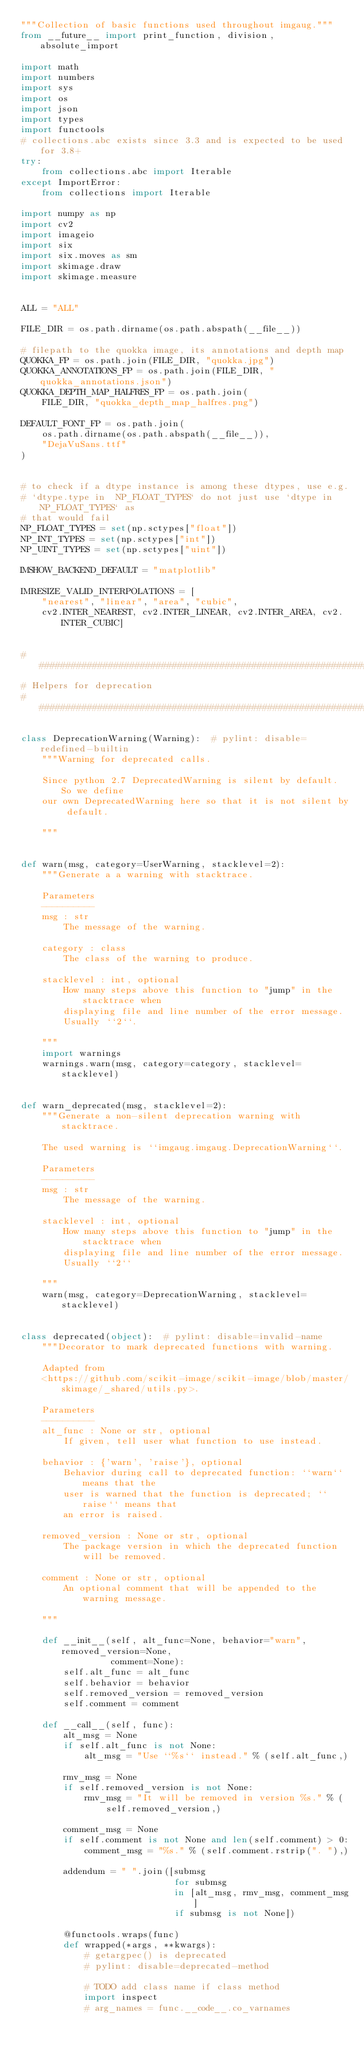<code> <loc_0><loc_0><loc_500><loc_500><_Python_>"""Collection of basic functions used throughout imgaug."""
from __future__ import print_function, division, absolute_import

import math
import numbers
import sys
import os
import json
import types
import functools
# collections.abc exists since 3.3 and is expected to be used for 3.8+
try:
    from collections.abc import Iterable
except ImportError:
    from collections import Iterable

import numpy as np
import cv2
import imageio
import six
import six.moves as sm
import skimage.draw
import skimage.measure


ALL = "ALL"

FILE_DIR = os.path.dirname(os.path.abspath(__file__))

# filepath to the quokka image, its annotations and depth map
QUOKKA_FP = os.path.join(FILE_DIR, "quokka.jpg")
QUOKKA_ANNOTATIONS_FP = os.path.join(FILE_DIR, "quokka_annotations.json")
QUOKKA_DEPTH_MAP_HALFRES_FP = os.path.join(
    FILE_DIR, "quokka_depth_map_halfres.png")

DEFAULT_FONT_FP = os.path.join(
    os.path.dirname(os.path.abspath(__file__)),
    "DejaVuSans.ttf"
)


# to check if a dtype instance is among these dtypes, use e.g.
# `dtype.type in  NP_FLOAT_TYPES` do not just use `dtype in NP_FLOAT_TYPES` as
# that would fail
NP_FLOAT_TYPES = set(np.sctypes["float"])
NP_INT_TYPES = set(np.sctypes["int"])
NP_UINT_TYPES = set(np.sctypes["uint"])

IMSHOW_BACKEND_DEFAULT = "matplotlib"

IMRESIZE_VALID_INTERPOLATIONS = [
    "nearest", "linear", "area", "cubic",
    cv2.INTER_NEAREST, cv2.INTER_LINEAR, cv2.INTER_AREA, cv2.INTER_CUBIC]


###############################################################################
# Helpers for deprecation
###############################################################################

class DeprecationWarning(Warning):  # pylint: disable=redefined-builtin
    """Warning for deprecated calls.

    Since python 2.7 DeprecatedWarning is silent by default. So we define
    our own DeprecatedWarning here so that it is not silent by default.

    """


def warn(msg, category=UserWarning, stacklevel=2):
    """Generate a a warning with stacktrace.

    Parameters
    ----------
    msg : str
        The message of the warning.

    category : class
        The class of the warning to produce.

    stacklevel : int, optional
        How many steps above this function to "jump" in the stacktrace when
        displaying file and line number of the error message.
        Usually ``2``.

    """
    import warnings
    warnings.warn(msg, category=category, stacklevel=stacklevel)


def warn_deprecated(msg, stacklevel=2):
    """Generate a non-silent deprecation warning with stacktrace.

    The used warning is ``imgaug.imgaug.DeprecationWarning``.

    Parameters
    ----------
    msg : str
        The message of the warning.

    stacklevel : int, optional
        How many steps above this function to "jump" in the stacktrace when
        displaying file and line number of the error message.
        Usually ``2``

    """
    warn(msg, category=DeprecationWarning, stacklevel=stacklevel)


class deprecated(object):  # pylint: disable=invalid-name
    """Decorator to mark deprecated functions with warning.

    Adapted from
    <https://github.com/scikit-image/scikit-image/blob/master/skimage/_shared/utils.py>.

    Parameters
    ----------
    alt_func : None or str, optional
        If given, tell user what function to use instead.

    behavior : {'warn', 'raise'}, optional
        Behavior during call to deprecated function: ``warn`` means that the
        user is warned that the function is deprecated; ``raise`` means that
        an error is raised.

    removed_version : None or str, optional
        The package version in which the deprecated function will be removed.

    comment : None or str, optional
        An optional comment that will be appended to the warning message.

    """

    def __init__(self, alt_func=None, behavior="warn", removed_version=None,
                 comment=None):
        self.alt_func = alt_func
        self.behavior = behavior
        self.removed_version = removed_version
        self.comment = comment

    def __call__(self, func):
        alt_msg = None
        if self.alt_func is not None:
            alt_msg = "Use ``%s`` instead." % (self.alt_func,)

        rmv_msg = None
        if self.removed_version is not None:
            rmv_msg = "It will be removed in version %s." % (
                self.removed_version,)

        comment_msg = None
        if self.comment is not None and len(self.comment) > 0:
            comment_msg = "%s." % (self.comment.rstrip(". "),)

        addendum = " ".join([submsg
                             for submsg
                             in [alt_msg, rmv_msg, comment_msg]
                             if submsg is not None])

        @functools.wraps(func)
        def wrapped(*args, **kwargs):
            # getargpec() is deprecated
            # pylint: disable=deprecated-method

            # TODO add class name if class method
            import inspect
            # arg_names = func.__code__.co_varnames
</code> 